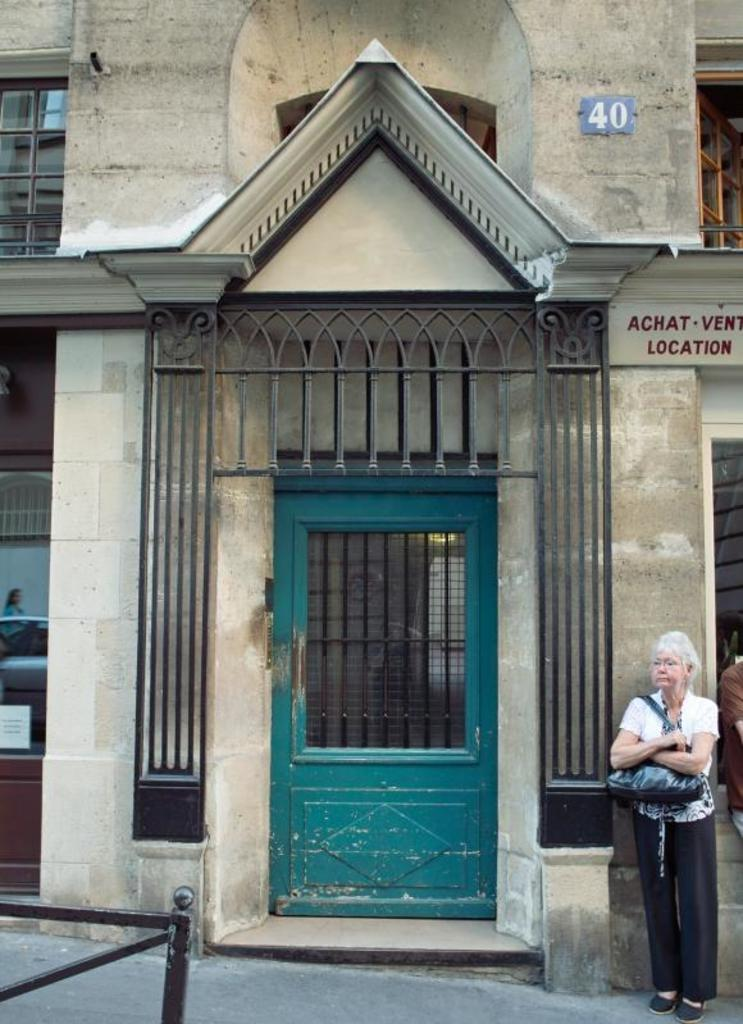What type of structure is visible in the image? There is a house in the image. What are some features of the house? The house has a roof, windows, and a door. Who is present in the image besides the house? There is a woman in the image. What is the woman wearing? The woman is wearing a bag. Where is the woman located in the image? The woman is standing on the road. Can you see the woman's brother holding a rifle in the image? There is no brother or rifle present in the image. 